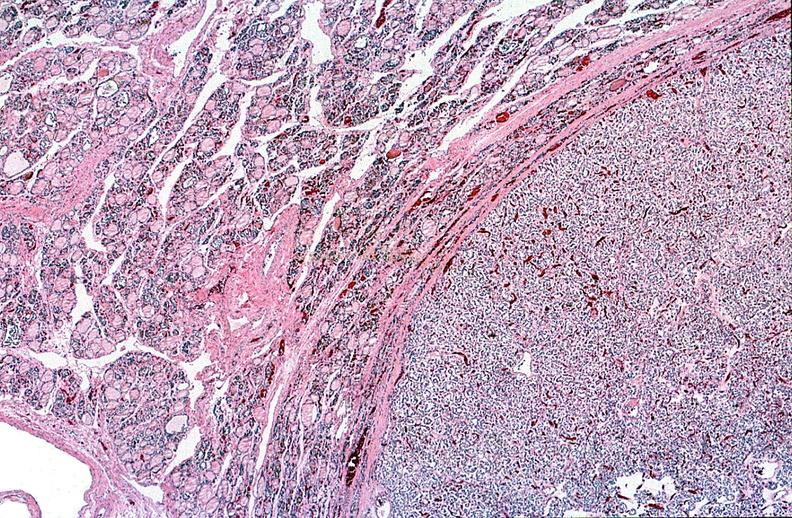s endocrine present?
Answer the question using a single word or phrase. Yes 